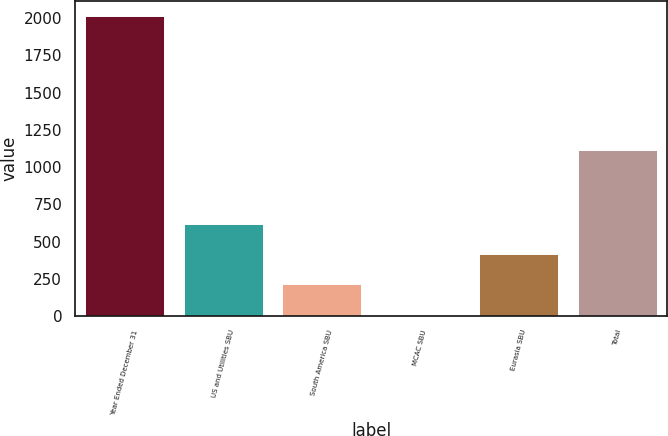<chart> <loc_0><loc_0><loc_500><loc_500><bar_chart><fcel>Year Ended December 31<fcel>US and Utilities SBU<fcel>South America SBU<fcel>MCAC SBU<fcel>Eurasia SBU<fcel>Total<nl><fcel>2018<fcel>615.6<fcel>213<fcel>5<fcel>414.3<fcel>1114<nl></chart> 